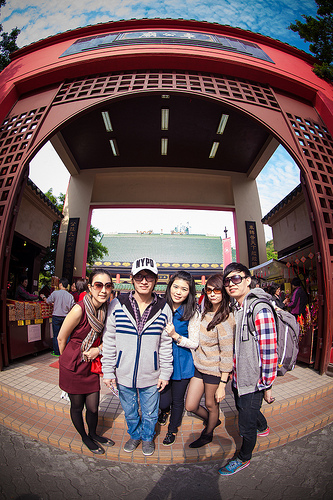<image>
Is there a glasses on the girl? No. The glasses is not positioned on the girl. They may be near each other, but the glasses is not supported by or resting on top of the girl. 